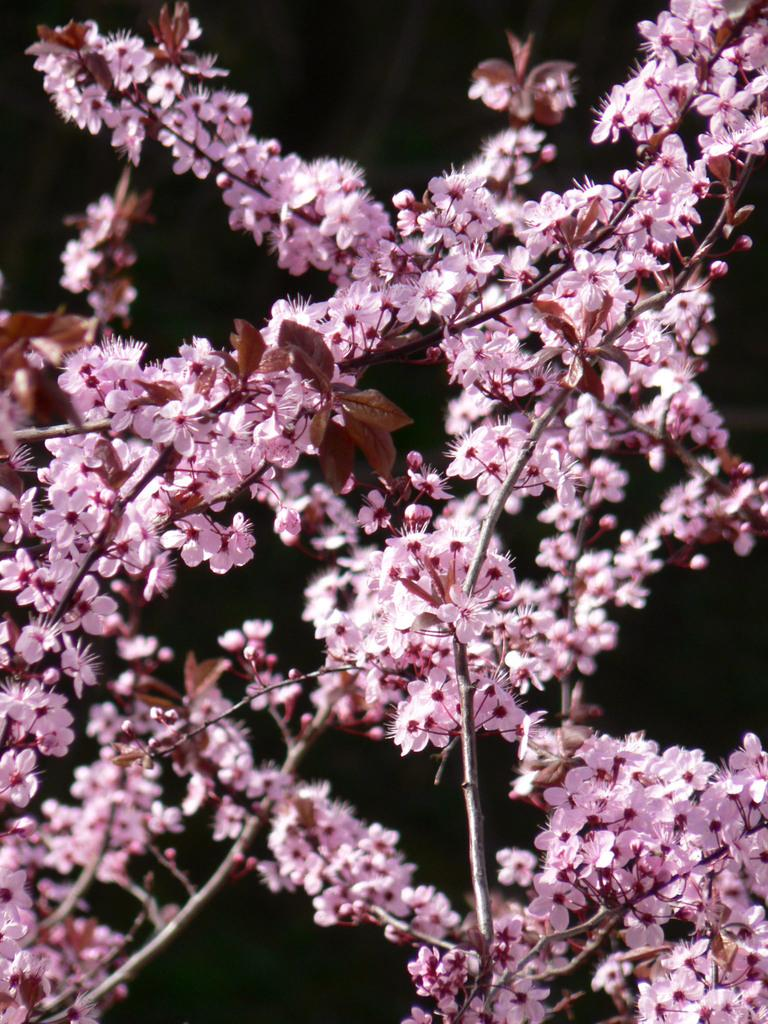What is the main subject of the image? There is a branch of flowers in the image. What can be seen in the background of the image? The background of the image is black. Can you tell me how many people are walking on the tramp in the image? There is no tramp or people walking in the image; it features a branch of flowers against a black background. 